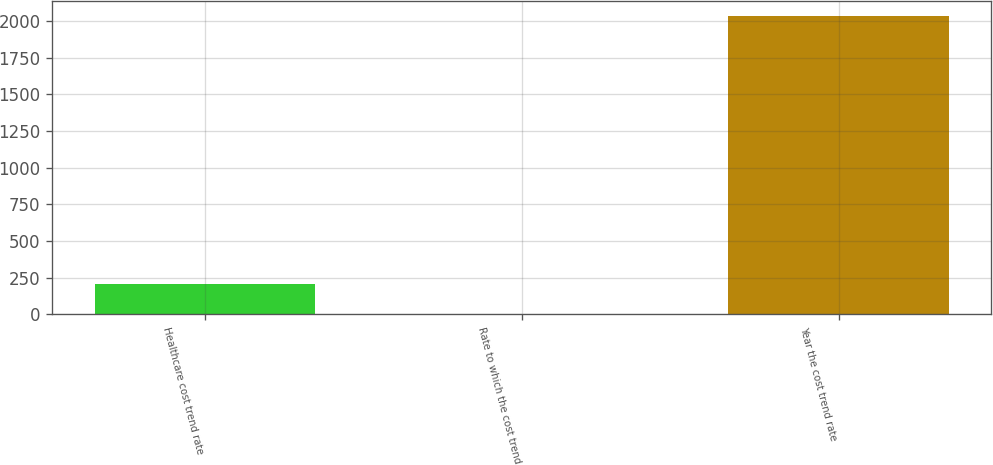Convert chart. <chart><loc_0><loc_0><loc_500><loc_500><bar_chart><fcel>Healthcare cost trend rate<fcel>Rate to which the cost trend<fcel>Year the cost trend rate<nl><fcel>207.76<fcel>4.4<fcel>2038<nl></chart> 